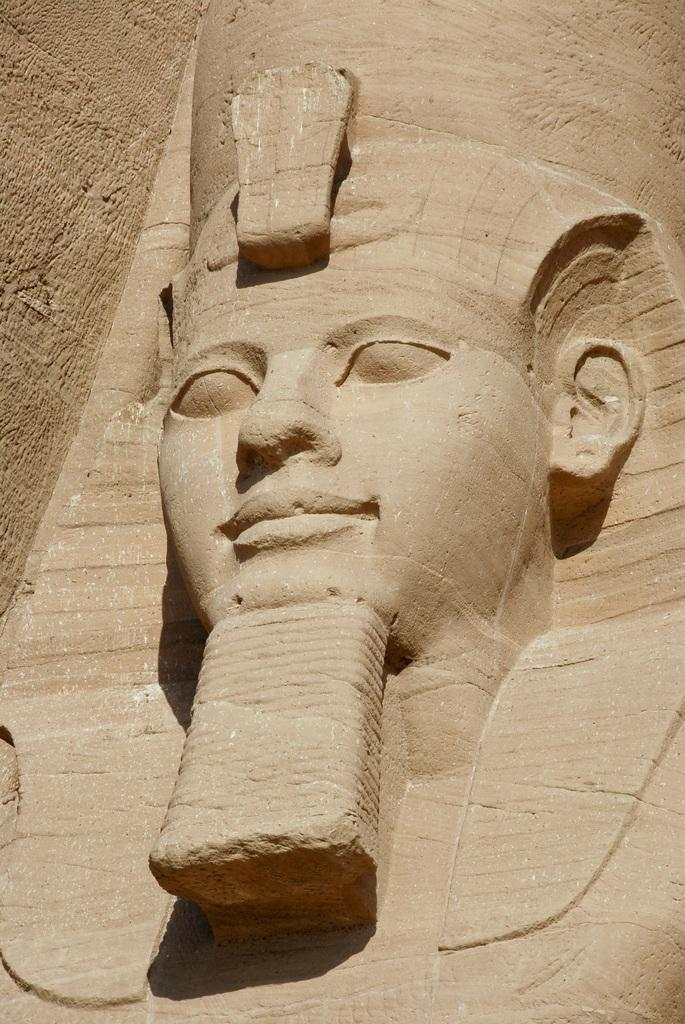What is the main subject in the center of the image? There is a sculpture in the center of the image. What can be seen in the background of the image? There is a wall visible in the background of the image. How many grapes are hanging from the sculpture in the image? There are no grapes present in the image; the main subject is a sculpture. How many cats can be seen interacting with the sculpture in the image? There are no cats present in the image; the main subject is a sculpture. 